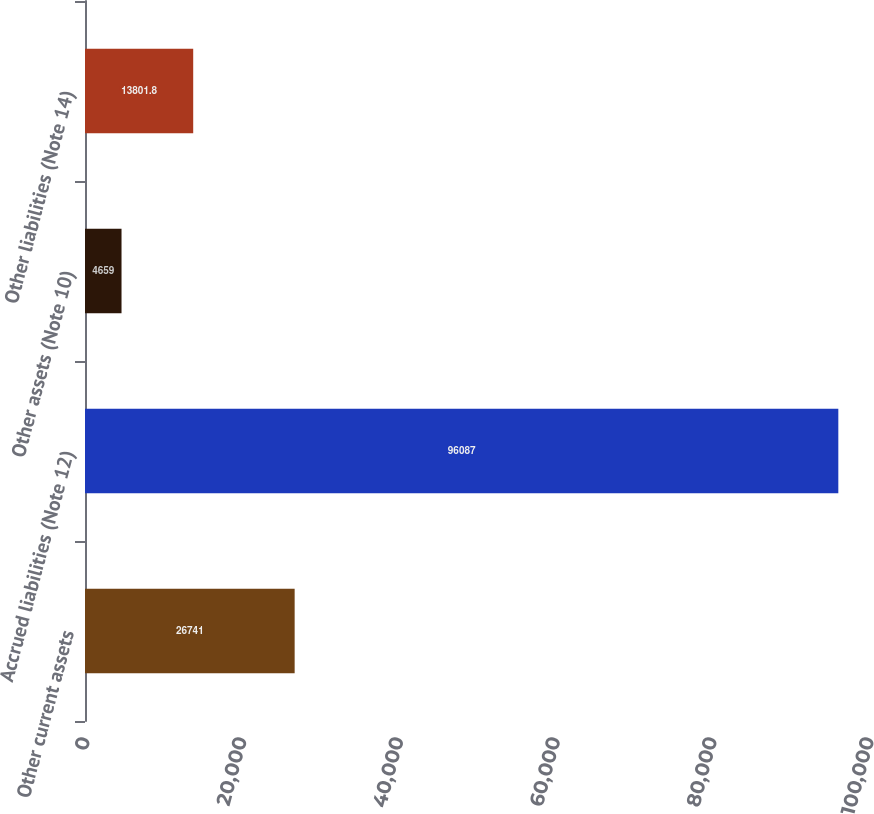<chart> <loc_0><loc_0><loc_500><loc_500><bar_chart><fcel>Other current assets<fcel>Accrued liabilities (Note 12)<fcel>Other assets (Note 10)<fcel>Other liabilities (Note 14)<nl><fcel>26741<fcel>96087<fcel>4659<fcel>13801.8<nl></chart> 